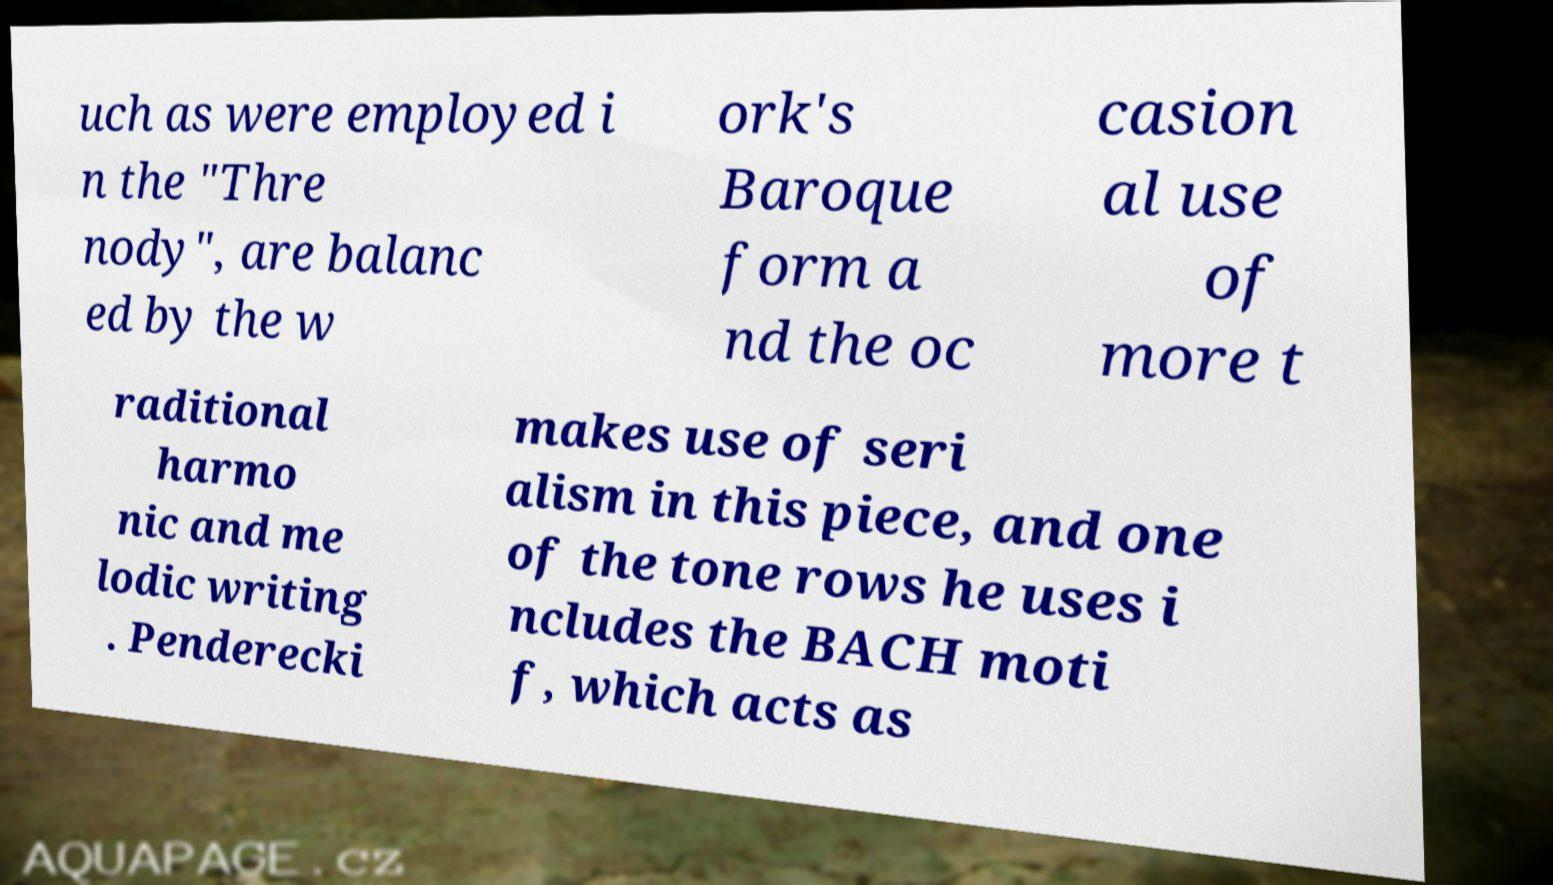Could you assist in decoding the text presented in this image and type it out clearly? uch as were employed i n the "Thre nody", are balanc ed by the w ork's Baroque form a nd the oc casion al use of more t raditional harmo nic and me lodic writing . Penderecki makes use of seri alism in this piece, and one of the tone rows he uses i ncludes the BACH moti f, which acts as 